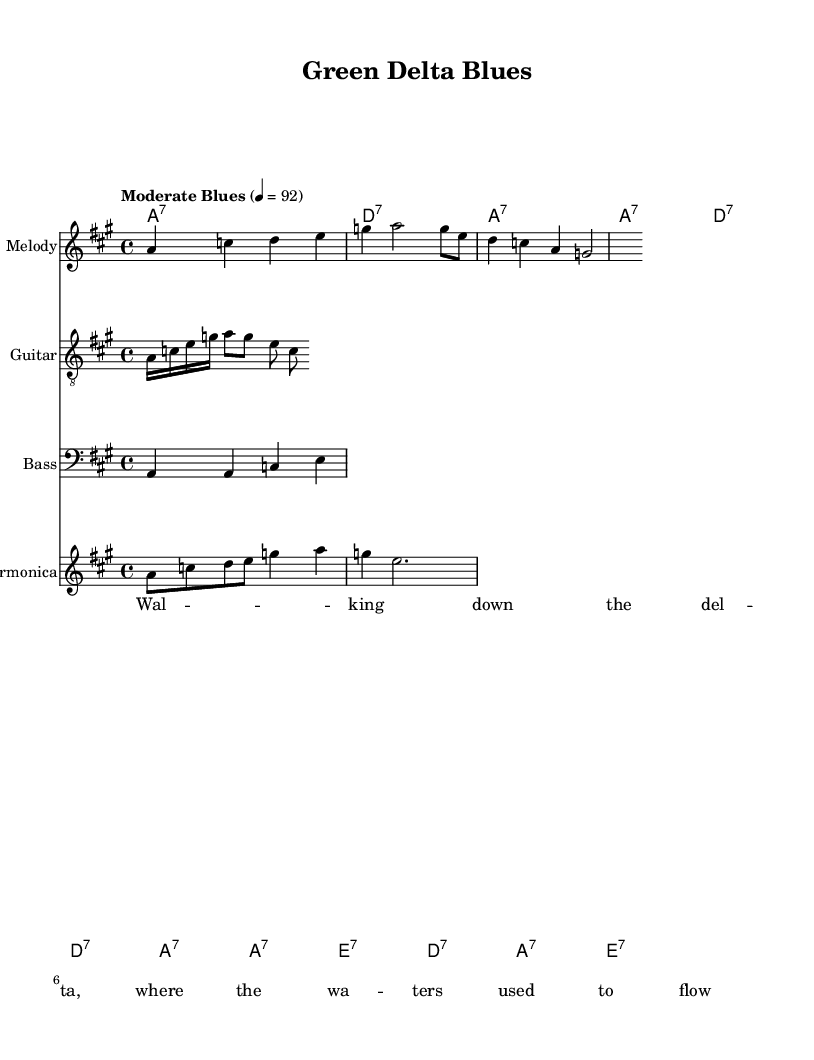What is the key signature of this music? The key signature is A major, which has three sharps: F#, C#, and G#.
Answer: A major What is the time signature of this music? The time signature indicated is 4/4, which means there are four beats per measure.
Answer: 4/4 What is the tempo marking of this piece? The tempo marking provided is "Moderate Blues" with a tempo of quarter note equals 92 beats per minute.
Answer: Moderate Blues, 92 How many measures are in the melody? The melody contains 3 measures, as seen by counting the groups of notes in the melody line.
Answer: 3 What type of music is represented in this sheet? The music represents Electric Blues, evident from the style and structure present in the melody and instrumentation.
Answer: Electric Blues What instrument primarily plays the melody in this sheet music? The melody is primarily played by a staff labeled "Melody," indicating that it is performed on a lead instrument.
Answer: Melody How many chord changes occur in the first section? The first section includes 4 chord changes, as identified by observing the chord symbols above each measure.
Answer: 4 